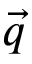Convert formula to latex. <formula><loc_0><loc_0><loc_500><loc_500>\vec { q }</formula> 